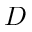Convert formula to latex. <formula><loc_0><loc_0><loc_500><loc_500>D</formula> 